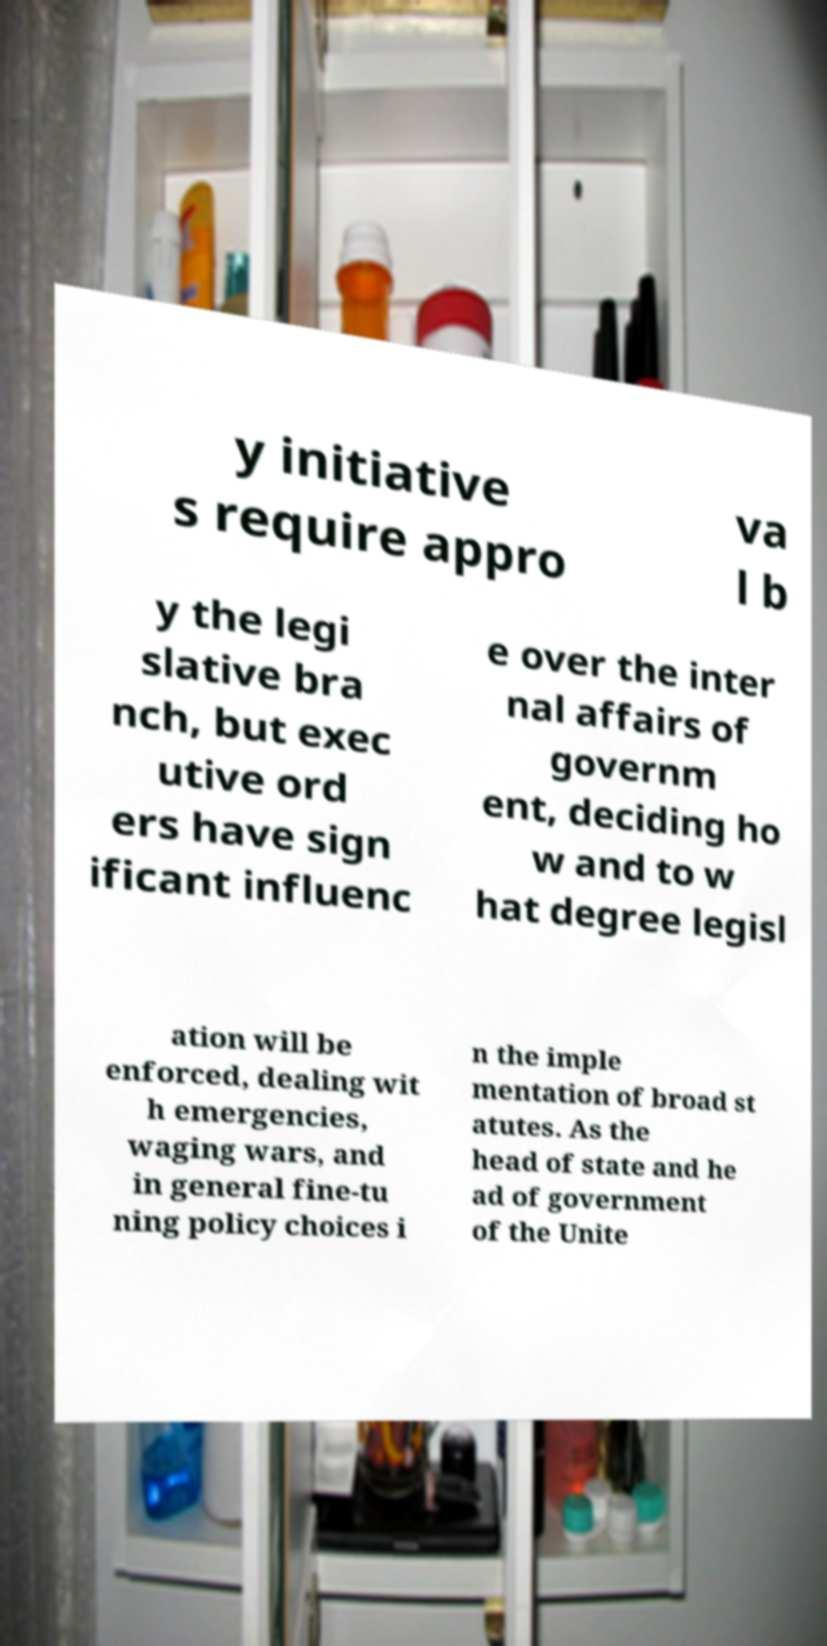There's text embedded in this image that I need extracted. Can you transcribe it verbatim? y initiative s require appro va l b y the legi slative bra nch, but exec utive ord ers have sign ificant influenc e over the inter nal affairs of governm ent, deciding ho w and to w hat degree legisl ation will be enforced, dealing wit h emergencies, waging wars, and in general fine-tu ning policy choices i n the imple mentation of broad st atutes. As the head of state and he ad of government of the Unite 